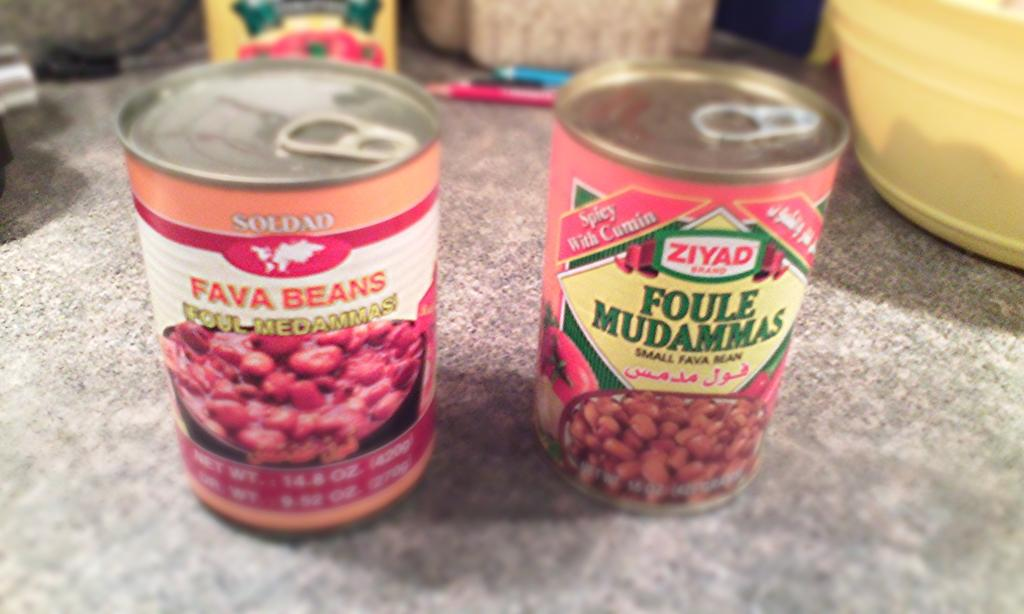<image>
Offer a succinct explanation of the picture presented. Two cans of beans, of the Soldad and Ziyad brands, are next to each other on a counter. 